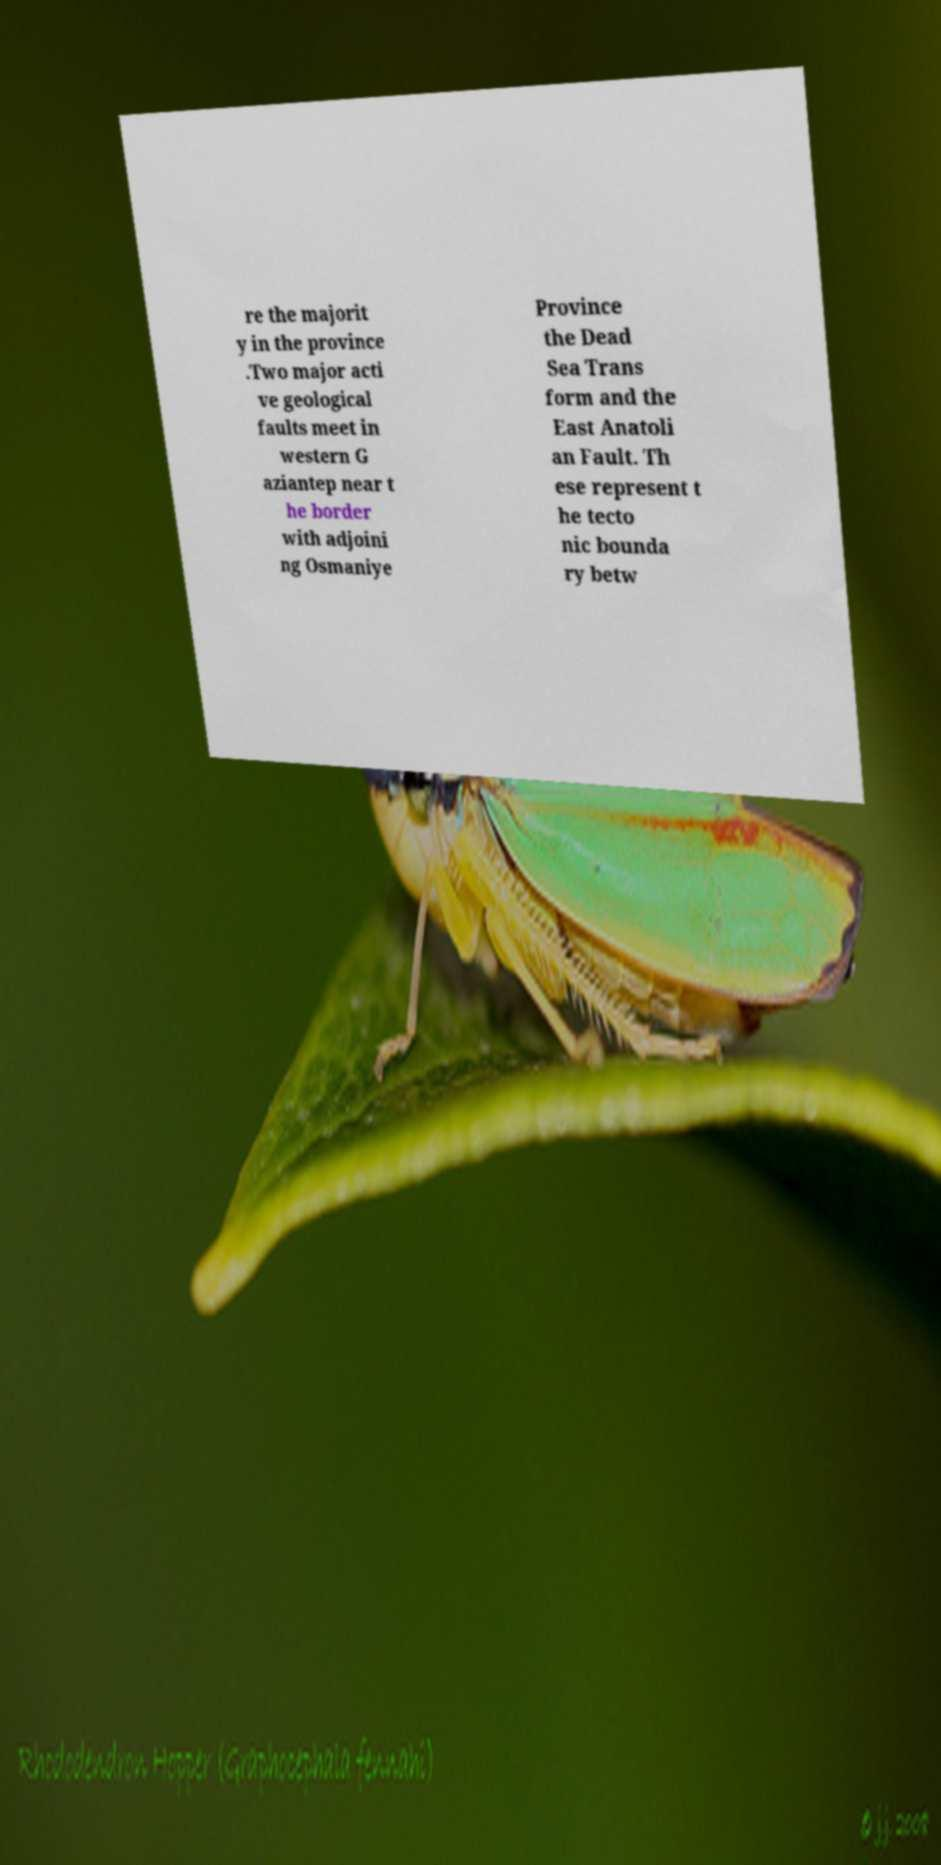Could you assist in decoding the text presented in this image and type it out clearly? re the majorit y in the province .Two major acti ve geological faults meet in western G aziantep near t he border with adjoini ng Osmaniye Province the Dead Sea Trans form and the East Anatoli an Fault. Th ese represent t he tecto nic bounda ry betw 